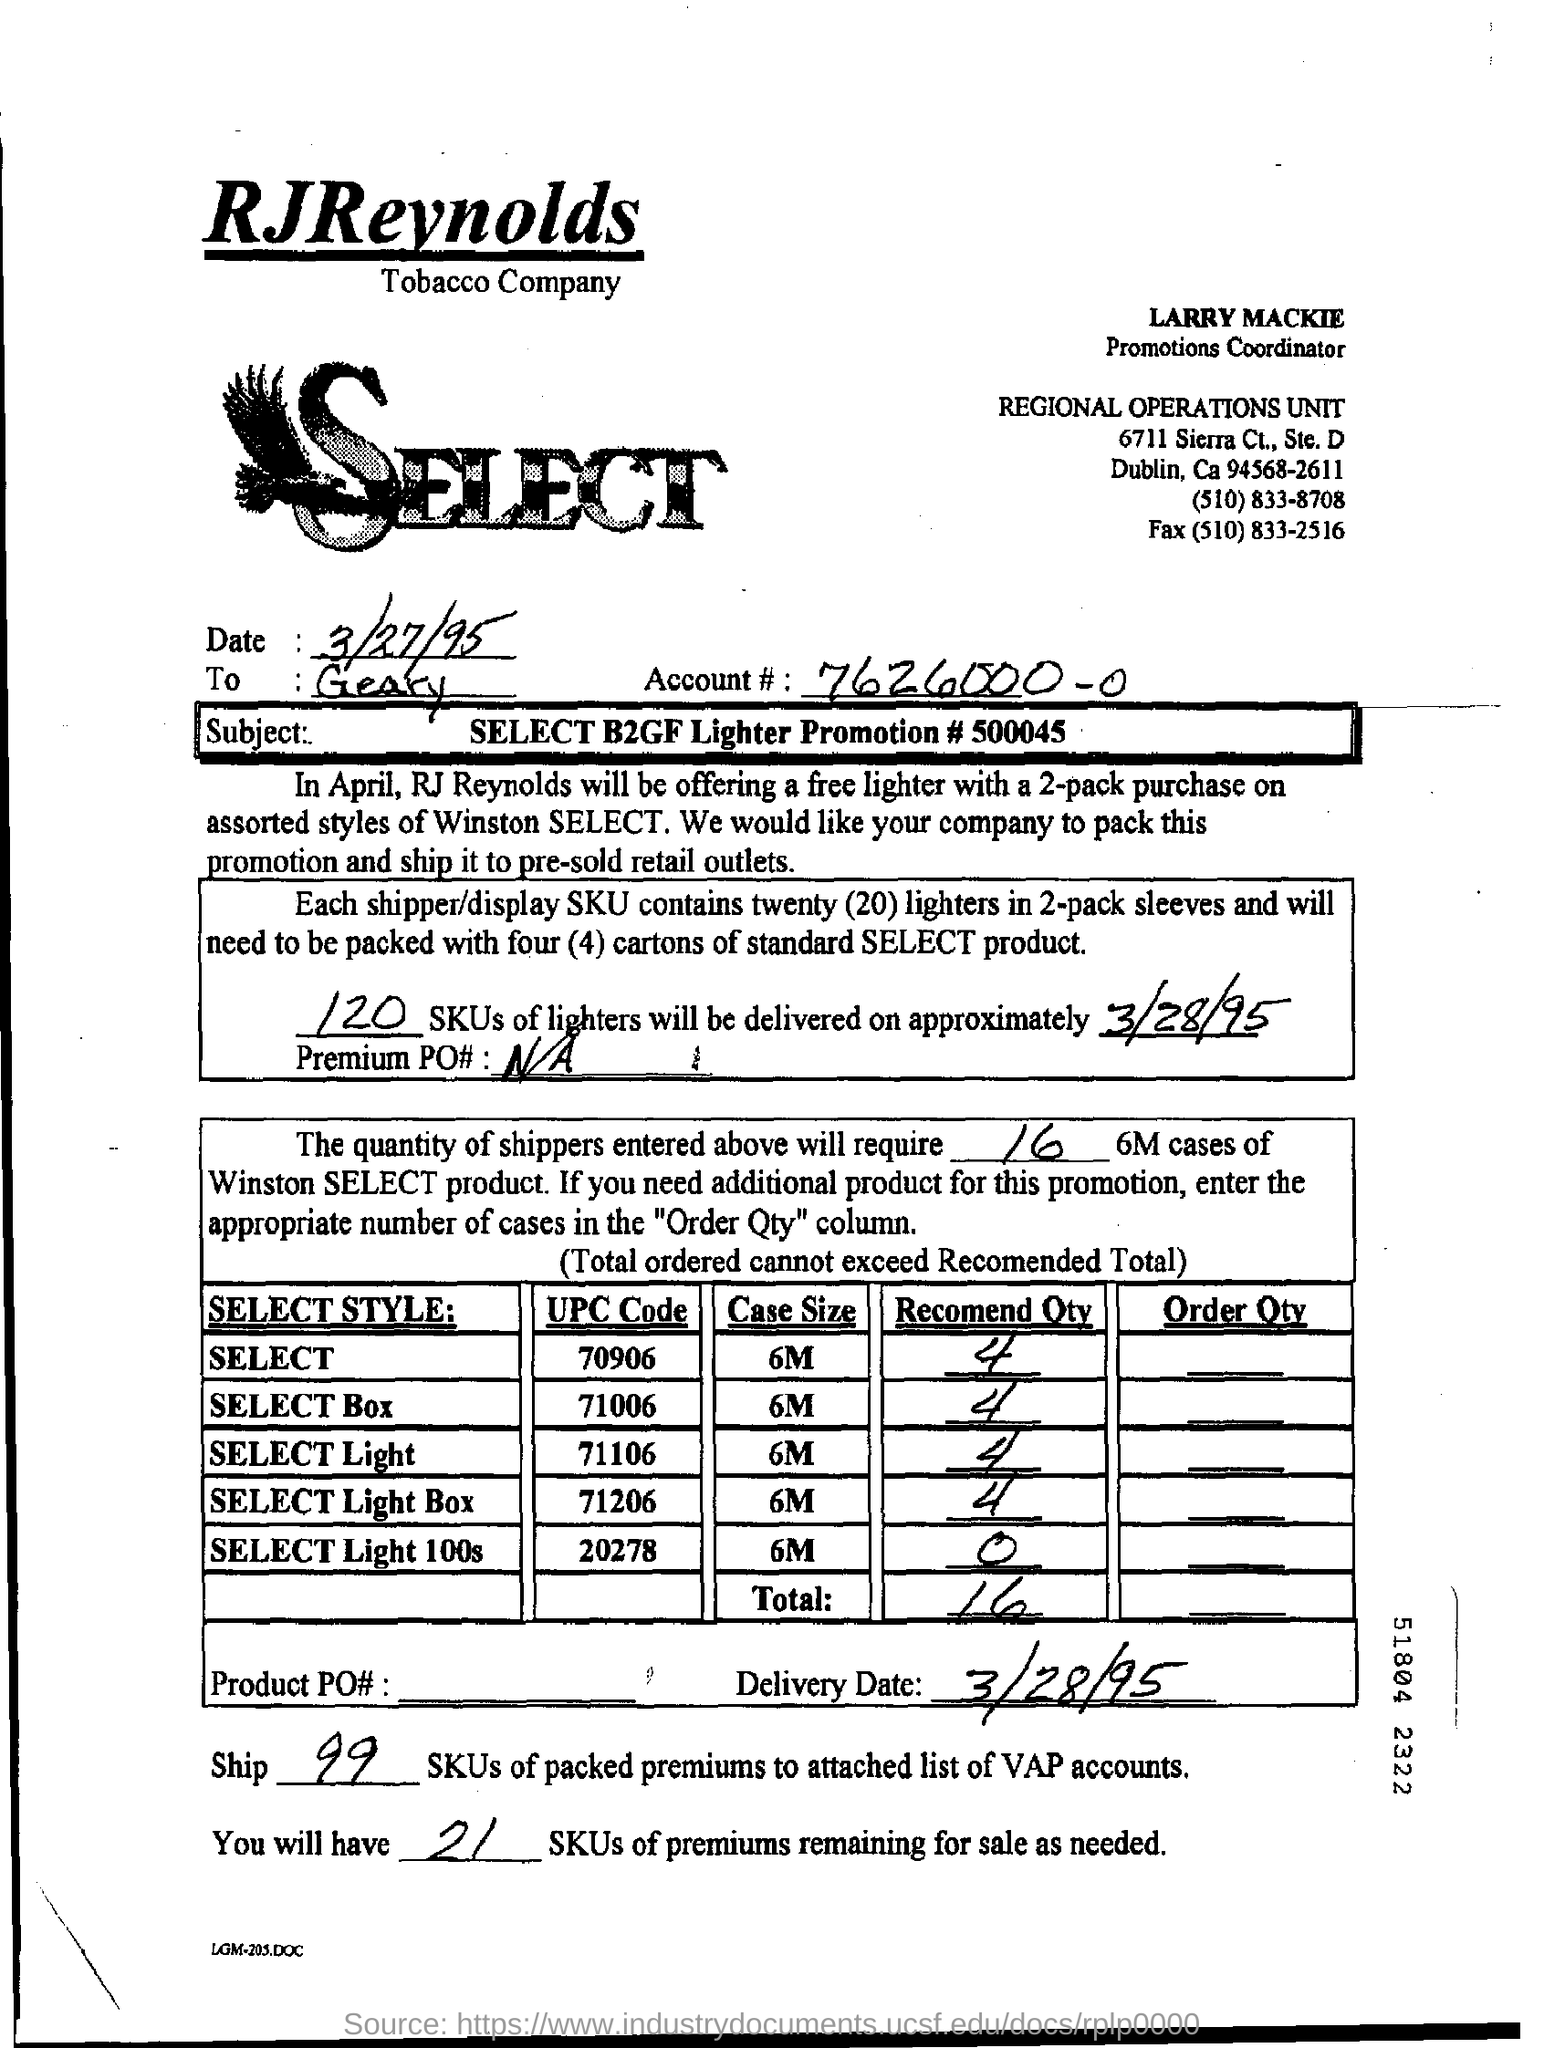Identify some key points in this picture. We will deliver 120 SKUs of lighters. The fax number for the Regional Operations Unit is (510) 833-2516. I am inquiring about the account number, which is 7626000-00. The delivery date is March 28, 1995. 